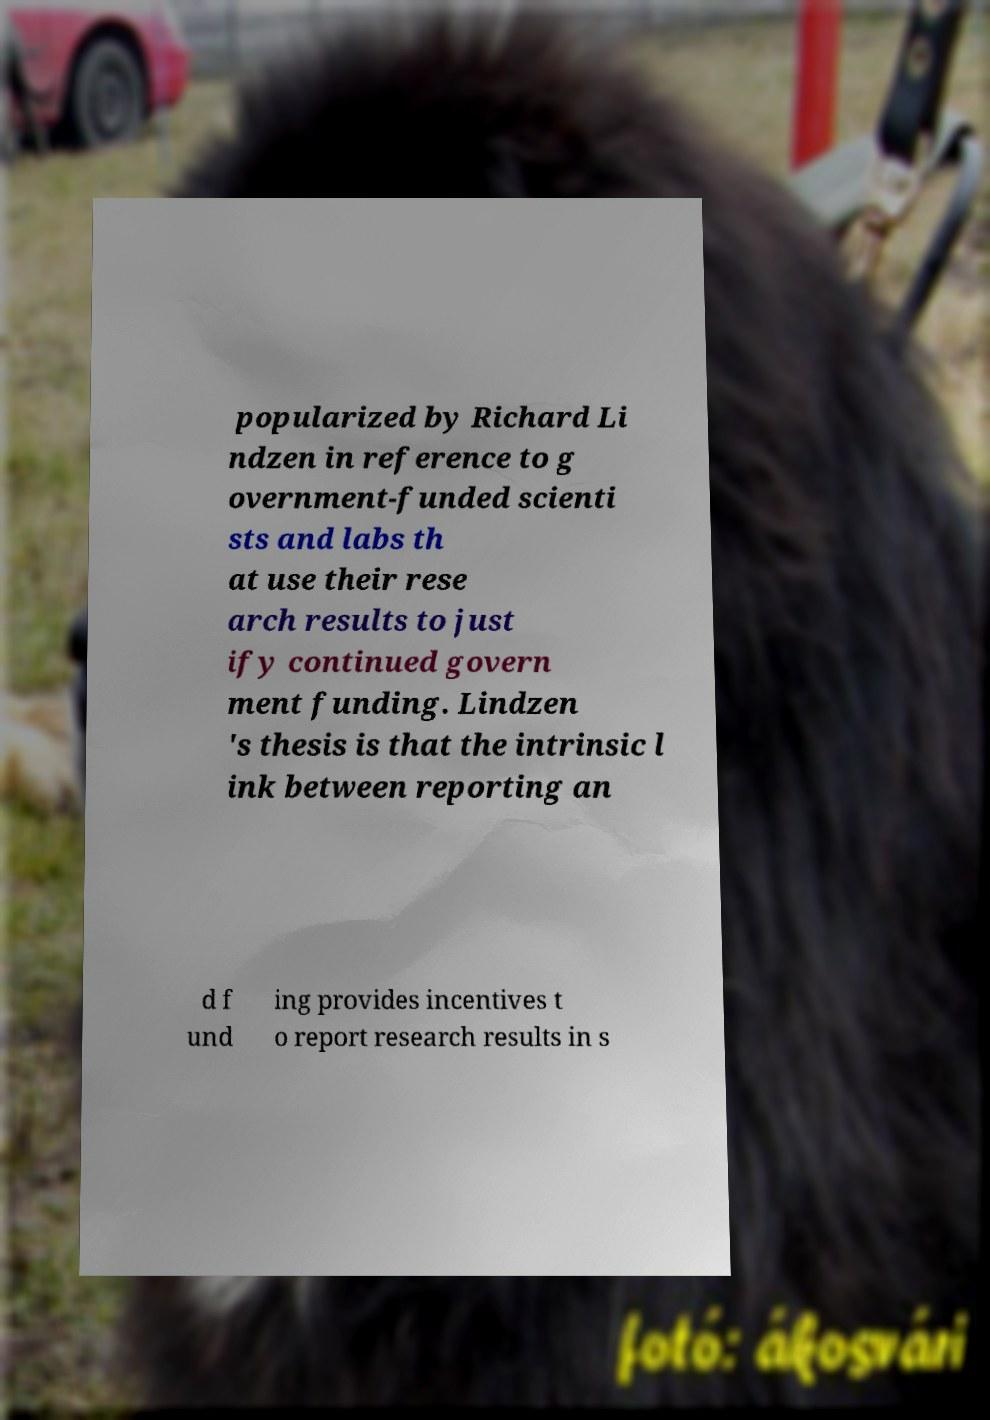I need the written content from this picture converted into text. Can you do that? popularized by Richard Li ndzen in reference to g overnment-funded scienti sts and labs th at use their rese arch results to just ify continued govern ment funding. Lindzen 's thesis is that the intrinsic l ink between reporting an d f und ing provides incentives t o report research results in s 